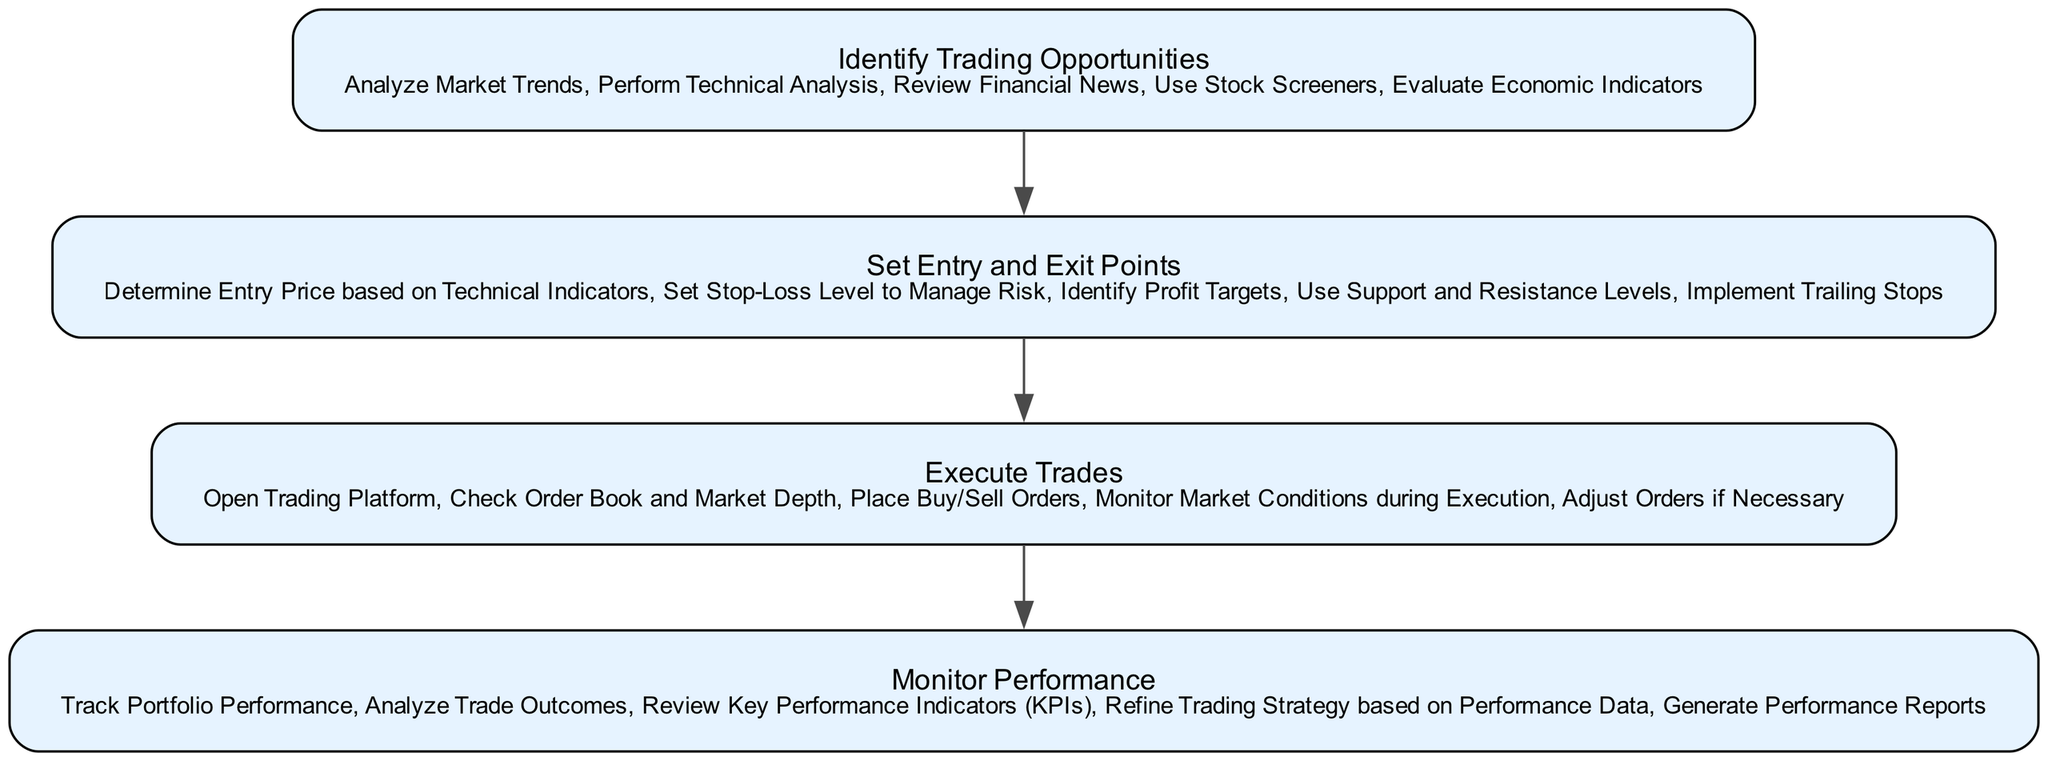What is the first step in the trading strategy execution? The first step mentioned in the diagram is "Identify Trading Opportunities." This is displayed as the initial node in the flow and serves as the starting point for the entire trading strategy.
Answer: Identify Trading Opportunities How many actions are listed under "Set Entry and Exit Points"? The node for "Set Entry and Exit Points" contains five distinct actions outlined within it. Counting these gives us the number of actions for this step.
Answer: Five What follows after "Execute Trades"? After the "Execute Trades" node, the next step shown in the diagram is "Monitor Performance." This indicates the sequential nature of the trading strategy.
Answer: Monitor Performance Which activity is directly related to risk management in the strategy? The action "Set Stop-Loss Level to Manage Risk" is specifically focused on risk management, which is part of the "Set Entry and Exit Points" node. This action highlights how traders mitigate potential losses.
Answer: Set Stop-Loss Level to Manage Risk What are the two main components of the trading strategy after identifying trading opportunities? After identifying trading opportunities, the two main components are "Set Entry and Exit Points" and "Execute Trades." These steps are sequentially arranged after the initial node in the diagram.
Answer: Set Entry and Exit Points, Execute Trades How many total nodes are present in the diagram? There are four nodes in the diagram, corresponding to the four major steps in the trading strategy execution process. Each step is represented as a separate node.
Answer: Four Which action involves analyzing the results of trades? The action "Analyze Trade Outcomes" is specifically about examining the results of trades and is part of the "Monitor Performance" step. This action is crucial in assessing the effectiveness of the trading strategy.
Answer: Analyze Trade Outcomes What action may require adjustments during execution? The action "Adjust Orders if Necessary" indicates that during the execution of trades, traders might need to modify their orders based on market conditions. This highlights the dynamic nature of trading execution.
Answer: Adjust Orders if Necessary Which action relies on market conditions to make decisions? "Monitor Market Conditions during Execution" relies on current market conditions to inform the decision-making process during the execution of trades, emphasizing real-time data utilization.
Answer: Monitor Market Conditions during Execution 